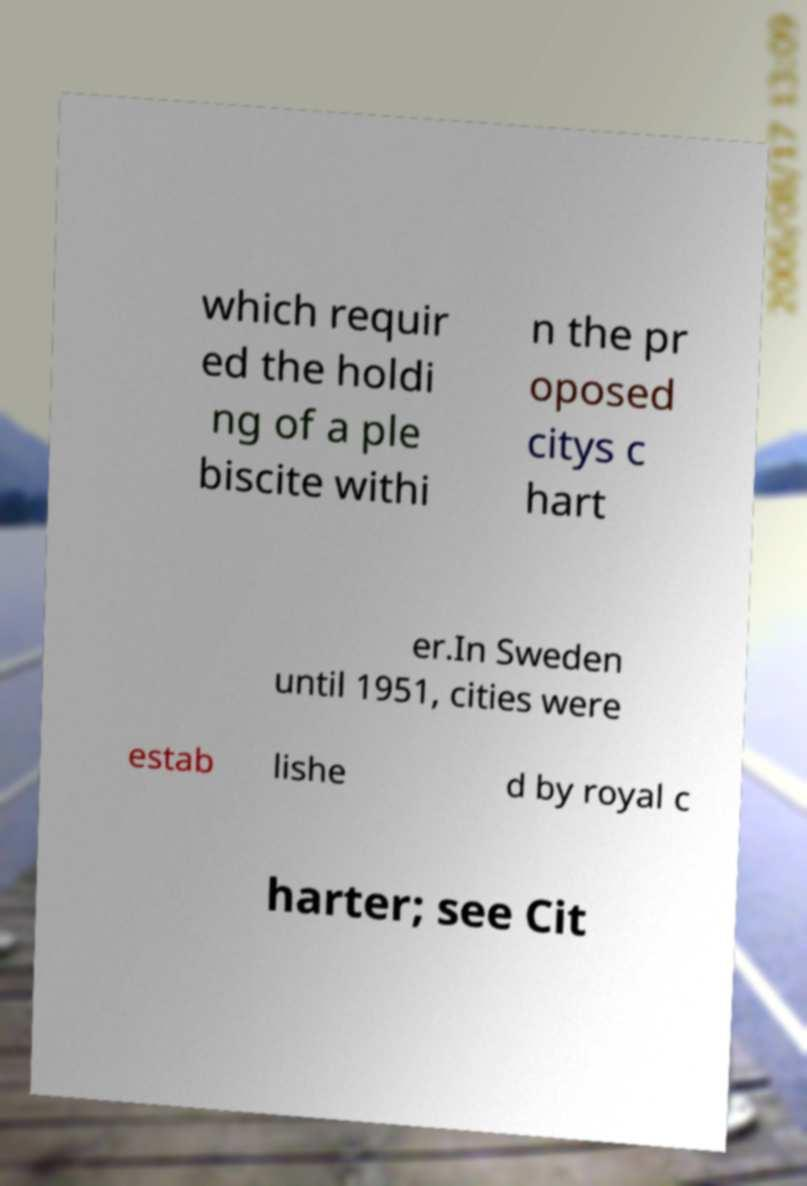Please read and relay the text visible in this image. What does it say? which requir ed the holdi ng of a ple biscite withi n the pr oposed citys c hart er.In Sweden until 1951, cities were estab lishe d by royal c harter; see Cit 